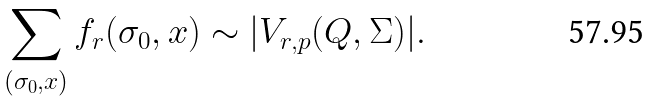<formula> <loc_0><loc_0><loc_500><loc_500>\sum _ { ( \sigma _ { 0 } , x ) } f _ { r } ( \sigma _ { 0 } , x ) \sim | V _ { r , p } ( Q , \Sigma ) | .</formula> 